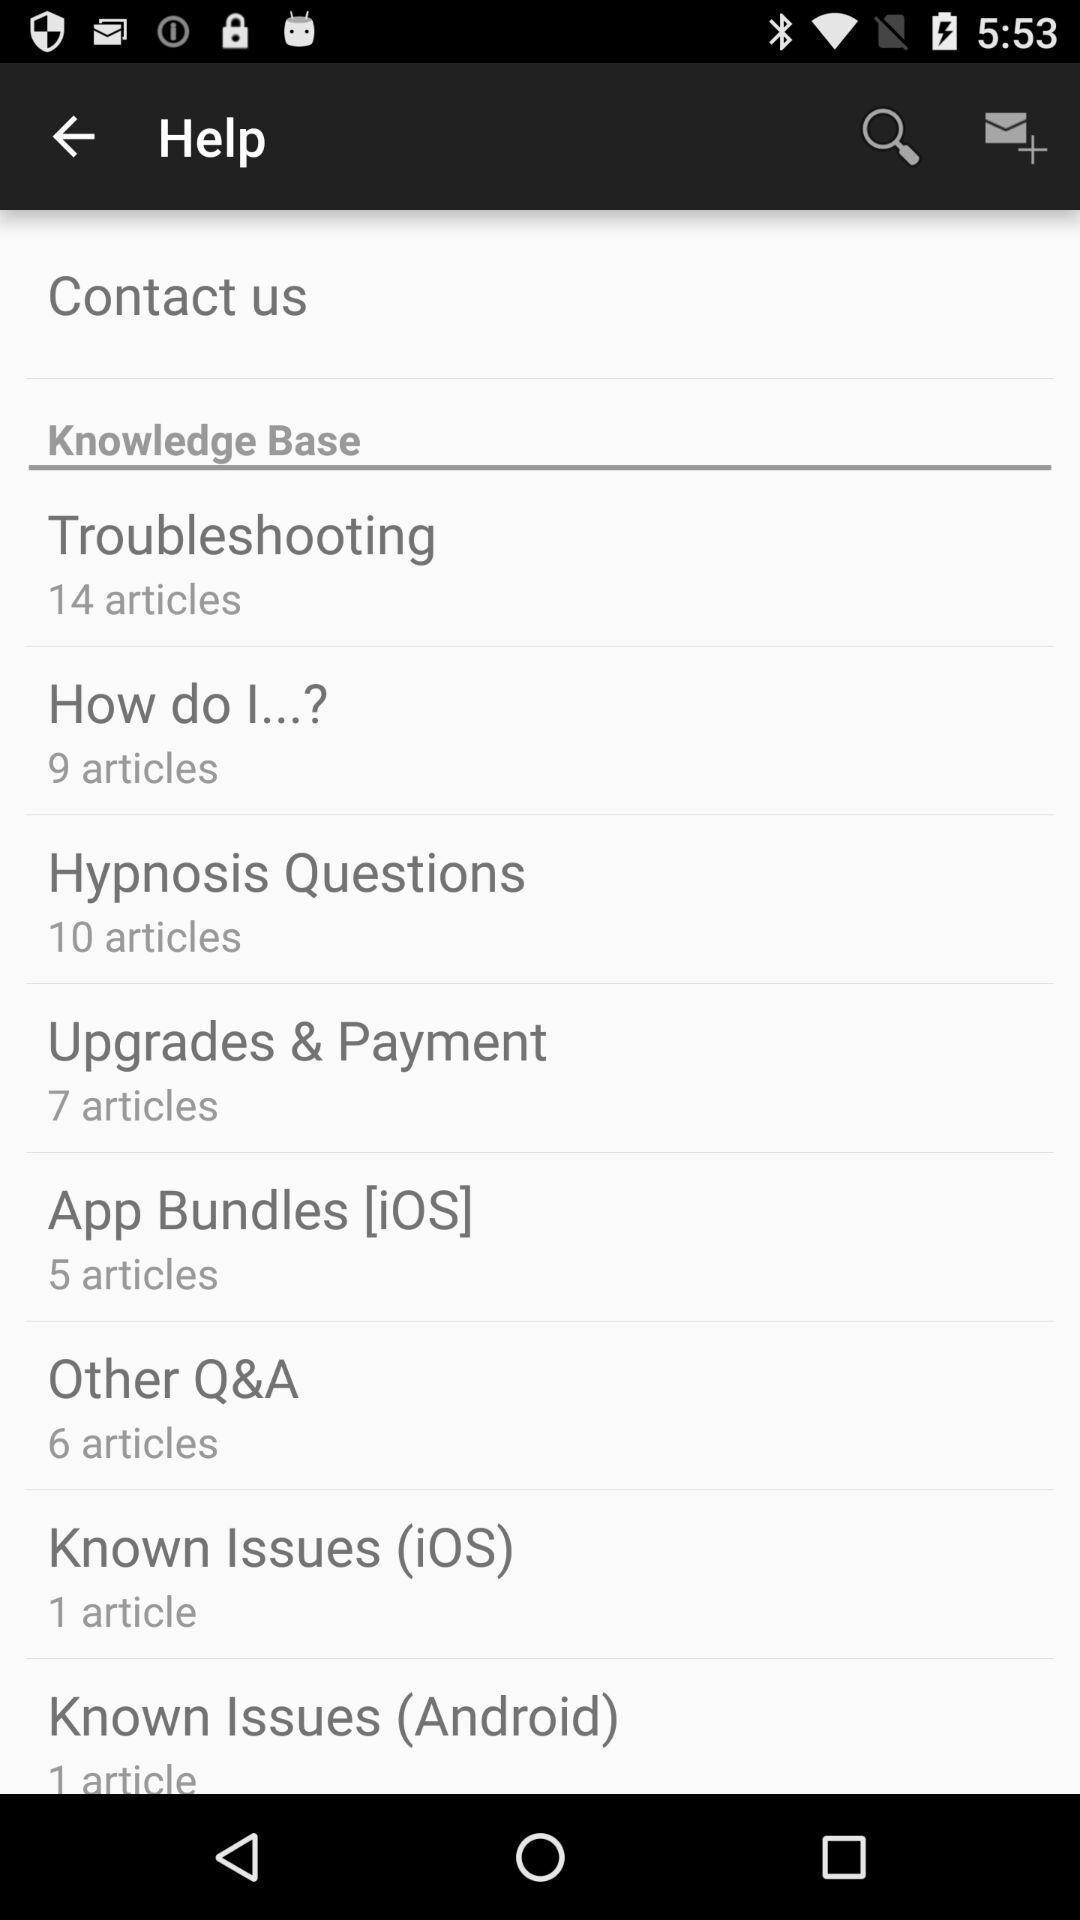Describe the key features of this screenshot. Page displaying list of help settings. 